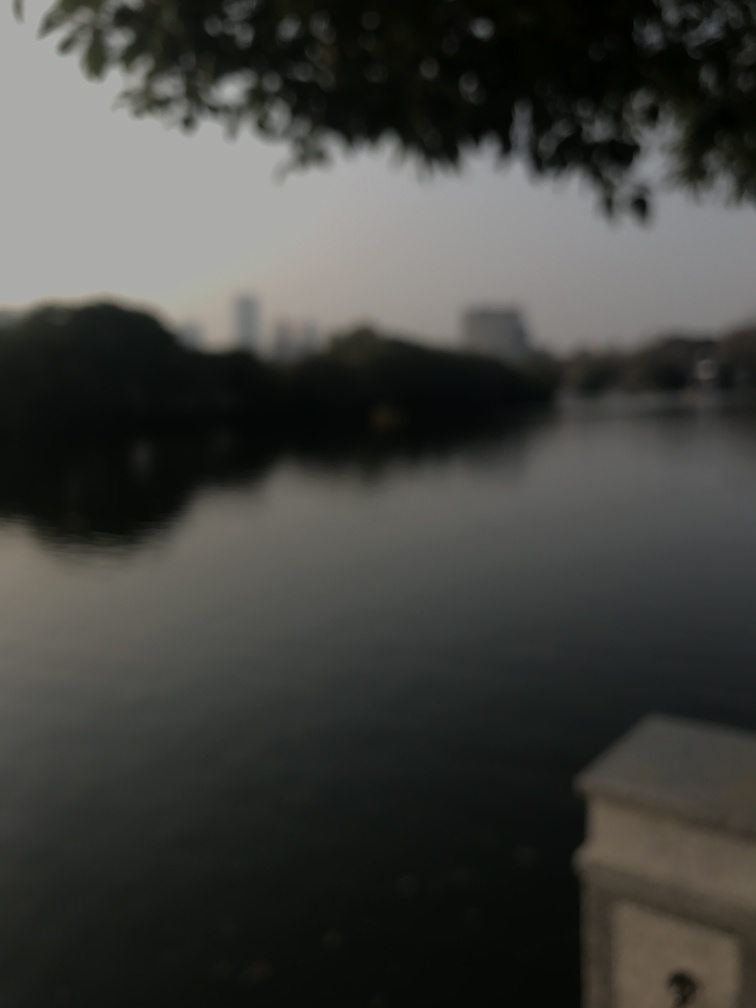What time of day does this image suggest? The subdued lighting and the absence of harsh shadows in the image suggest it is either dawn or dusk, times known for their softer light. The overall calmness of the scene also supports this time frame, often associated with quiet and less human activity. 